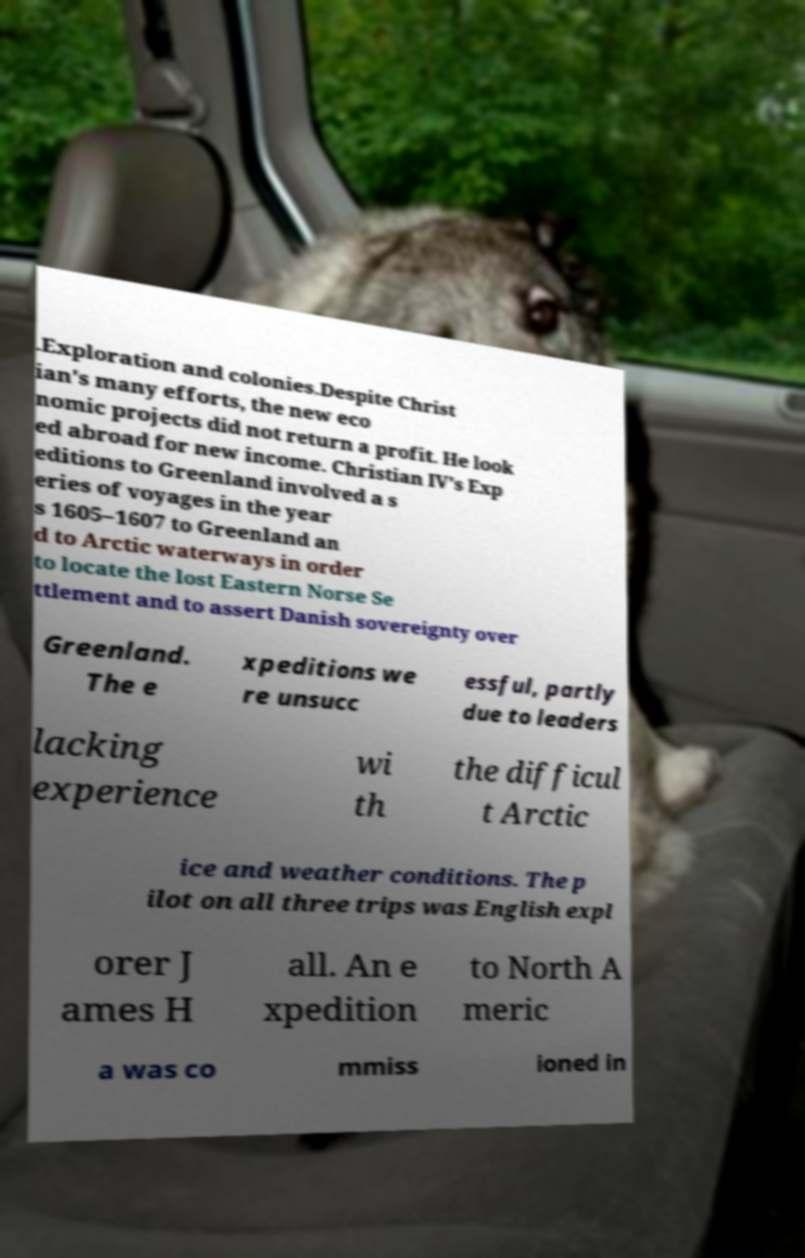For documentation purposes, I need the text within this image transcribed. Could you provide that? .Exploration and colonies.Despite Christ ian's many efforts, the new eco nomic projects did not return a profit. He look ed abroad for new income. Christian IV's Exp editions to Greenland involved a s eries of voyages in the year s 1605–1607 to Greenland an d to Arctic waterways in order to locate the lost Eastern Norse Se ttlement and to assert Danish sovereignty over Greenland. The e xpeditions we re unsucc essful, partly due to leaders lacking experience wi th the difficul t Arctic ice and weather conditions. The p ilot on all three trips was English expl orer J ames H all. An e xpedition to North A meric a was co mmiss ioned in 